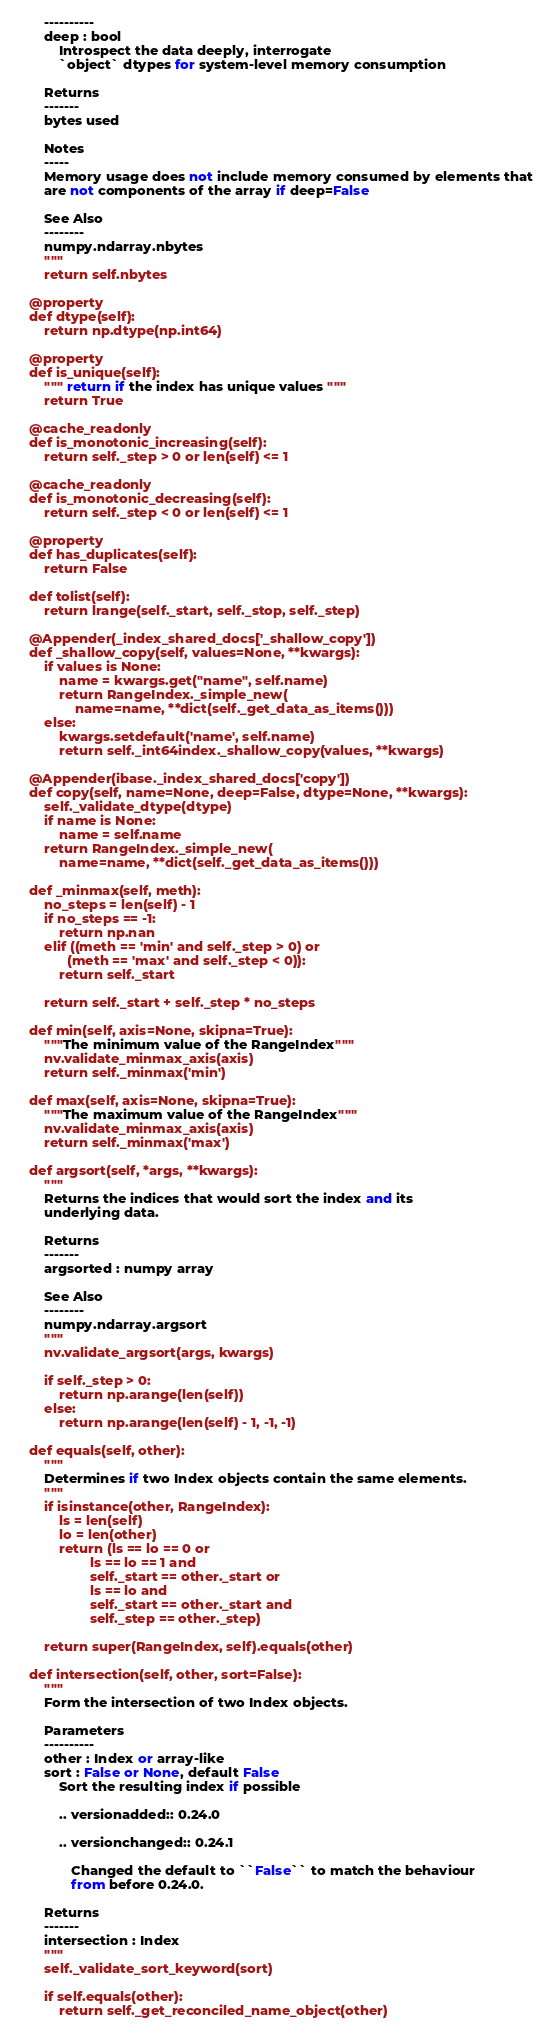<code> <loc_0><loc_0><loc_500><loc_500><_Python_>        ----------
        deep : bool
            Introspect the data deeply, interrogate
            `object` dtypes for system-level memory consumption

        Returns
        -------
        bytes used

        Notes
        -----
        Memory usage does not include memory consumed by elements that
        are not components of the array if deep=False

        See Also
        --------
        numpy.ndarray.nbytes
        """
        return self.nbytes

    @property
    def dtype(self):
        return np.dtype(np.int64)

    @property
    def is_unique(self):
        """ return if the index has unique values """
        return True

    @cache_readonly
    def is_monotonic_increasing(self):
        return self._step > 0 or len(self) <= 1

    @cache_readonly
    def is_monotonic_decreasing(self):
        return self._step < 0 or len(self) <= 1

    @property
    def has_duplicates(self):
        return False

    def tolist(self):
        return lrange(self._start, self._stop, self._step)

    @Appender(_index_shared_docs['_shallow_copy'])
    def _shallow_copy(self, values=None, **kwargs):
        if values is None:
            name = kwargs.get("name", self.name)
            return RangeIndex._simple_new(
                name=name, **dict(self._get_data_as_items()))
        else:
            kwargs.setdefault('name', self.name)
            return self._int64index._shallow_copy(values, **kwargs)

    @Appender(ibase._index_shared_docs['copy'])
    def copy(self, name=None, deep=False, dtype=None, **kwargs):
        self._validate_dtype(dtype)
        if name is None:
            name = self.name
        return RangeIndex._simple_new(
            name=name, **dict(self._get_data_as_items()))

    def _minmax(self, meth):
        no_steps = len(self) - 1
        if no_steps == -1:
            return np.nan
        elif ((meth == 'min' and self._step > 0) or
              (meth == 'max' and self._step < 0)):
            return self._start

        return self._start + self._step * no_steps

    def min(self, axis=None, skipna=True):
        """The minimum value of the RangeIndex"""
        nv.validate_minmax_axis(axis)
        return self._minmax('min')

    def max(self, axis=None, skipna=True):
        """The maximum value of the RangeIndex"""
        nv.validate_minmax_axis(axis)
        return self._minmax('max')

    def argsort(self, *args, **kwargs):
        """
        Returns the indices that would sort the index and its
        underlying data.

        Returns
        -------
        argsorted : numpy array

        See Also
        --------
        numpy.ndarray.argsort
        """
        nv.validate_argsort(args, kwargs)

        if self._step > 0:
            return np.arange(len(self))
        else:
            return np.arange(len(self) - 1, -1, -1)

    def equals(self, other):
        """
        Determines if two Index objects contain the same elements.
        """
        if isinstance(other, RangeIndex):
            ls = len(self)
            lo = len(other)
            return (ls == lo == 0 or
                    ls == lo == 1 and
                    self._start == other._start or
                    ls == lo and
                    self._start == other._start and
                    self._step == other._step)

        return super(RangeIndex, self).equals(other)

    def intersection(self, other, sort=False):
        """
        Form the intersection of two Index objects.

        Parameters
        ----------
        other : Index or array-like
        sort : False or None, default False
            Sort the resulting index if possible

            .. versionadded:: 0.24.0

            .. versionchanged:: 0.24.1

               Changed the default to ``False`` to match the behaviour
               from before 0.24.0.

        Returns
        -------
        intersection : Index
        """
        self._validate_sort_keyword(sort)

        if self.equals(other):
            return self._get_reconciled_name_object(other)
</code> 